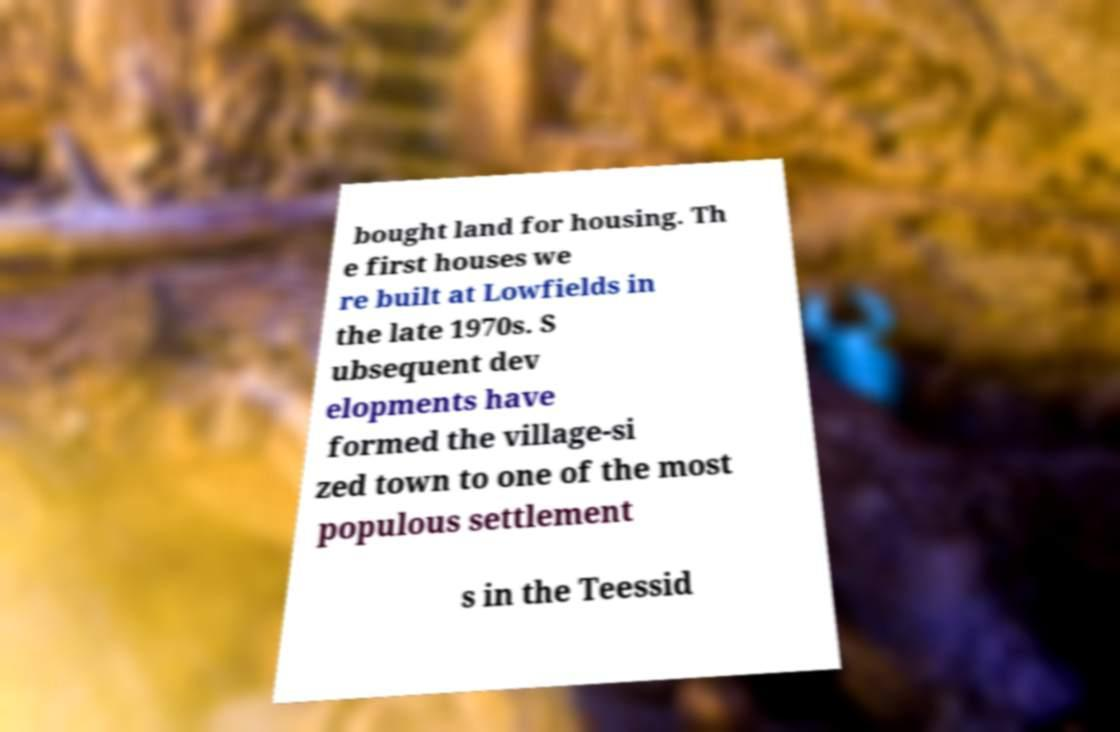For documentation purposes, I need the text within this image transcribed. Could you provide that? bought land for housing. Th e first houses we re built at Lowfields in the late 1970s. S ubsequent dev elopments have formed the village-si zed town to one of the most populous settlement s in the Teessid 